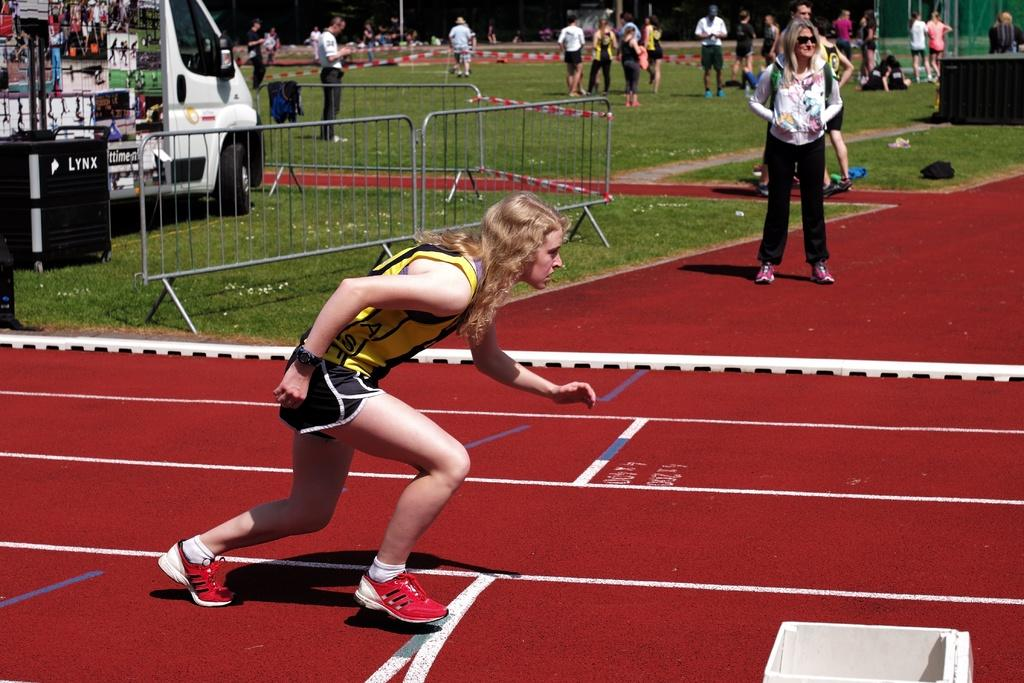<image>
Render a clear and concise summary of the photo. A Lynx logo can be seen on a black surface behind a runner on a track. 